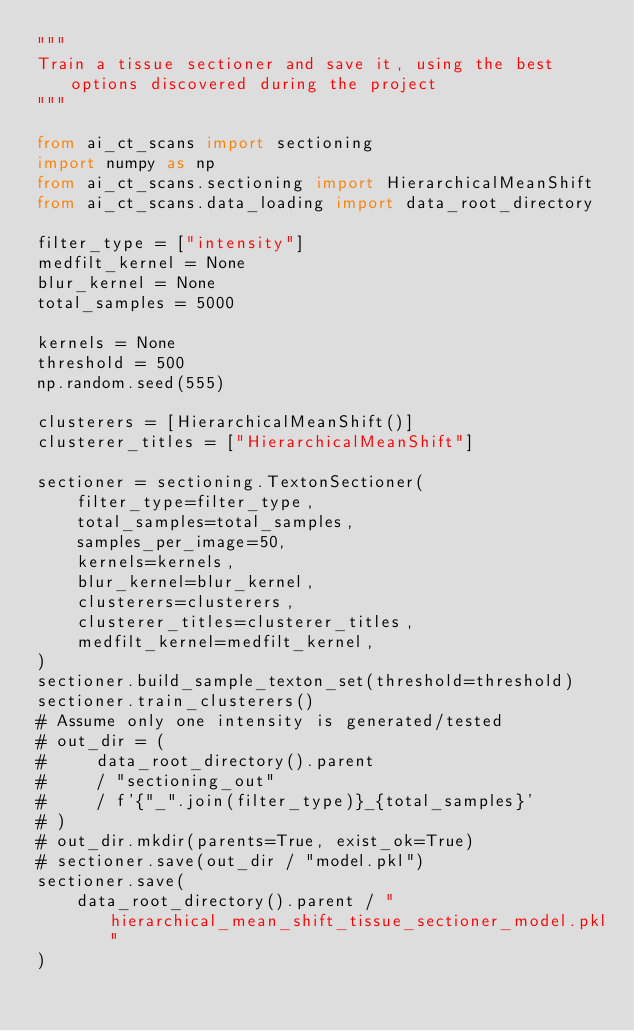Convert code to text. <code><loc_0><loc_0><loc_500><loc_500><_Python_>"""
Train a tissue sectioner and save it, using the best options discovered during the project
"""

from ai_ct_scans import sectioning
import numpy as np
from ai_ct_scans.sectioning import HierarchicalMeanShift
from ai_ct_scans.data_loading import data_root_directory

filter_type = ["intensity"]
medfilt_kernel = None
blur_kernel = None
total_samples = 5000

kernels = None
threshold = 500
np.random.seed(555)

clusterers = [HierarchicalMeanShift()]
clusterer_titles = ["HierarchicalMeanShift"]

sectioner = sectioning.TextonSectioner(
    filter_type=filter_type,
    total_samples=total_samples,
    samples_per_image=50,
    kernels=kernels,
    blur_kernel=blur_kernel,
    clusterers=clusterers,
    clusterer_titles=clusterer_titles,
    medfilt_kernel=medfilt_kernel,
)
sectioner.build_sample_texton_set(threshold=threshold)
sectioner.train_clusterers()
# Assume only one intensity is generated/tested
# out_dir = (
#     data_root_directory().parent
#     / "sectioning_out"
#     / f'{"_".join(filter_type)}_{total_samples}'
# )
# out_dir.mkdir(parents=True, exist_ok=True)
# sectioner.save(out_dir / "model.pkl")
sectioner.save(
    data_root_directory().parent / "hierarchical_mean_shift_tissue_sectioner_model.pkl"
)
</code> 